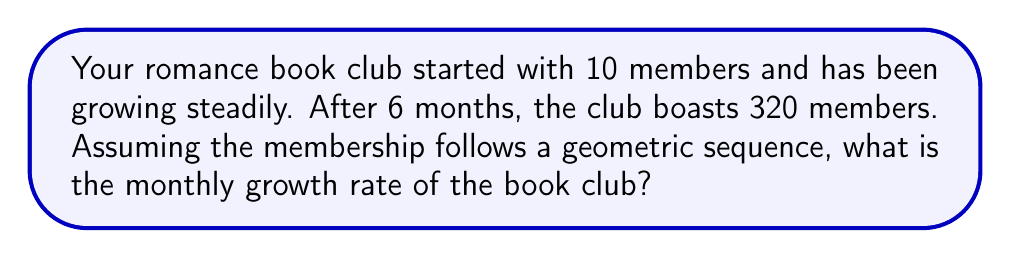Teach me how to tackle this problem. Let's approach this step-by-step:

1) In a geometric sequence, each term is a constant multiple of the previous term. Let's call this constant $r$, which represents the monthly growth rate plus 1.

2) We can express this as an equation:
   $10 \cdot r^6 = 320$

3) Dividing both sides by 10:
   $r^6 = 32$

4) Taking the 6th root of both sides:
   $r = \sqrt[6]{32}$

5) Calculate this value:
   $r \approx 1.7818$

6) To get the growth rate as a percentage, we subtract 1 and multiply by 100:
   Growth rate = $(r - 1) \cdot 100\%$
                $\approx (1.7818 - 1) \cdot 100\%$
                $\approx 0.7818 \cdot 100\%$
                $\approx 78.18\%$

Therefore, the monthly growth rate of the book club is approximately 78.18%.
Answer: 78.18% 